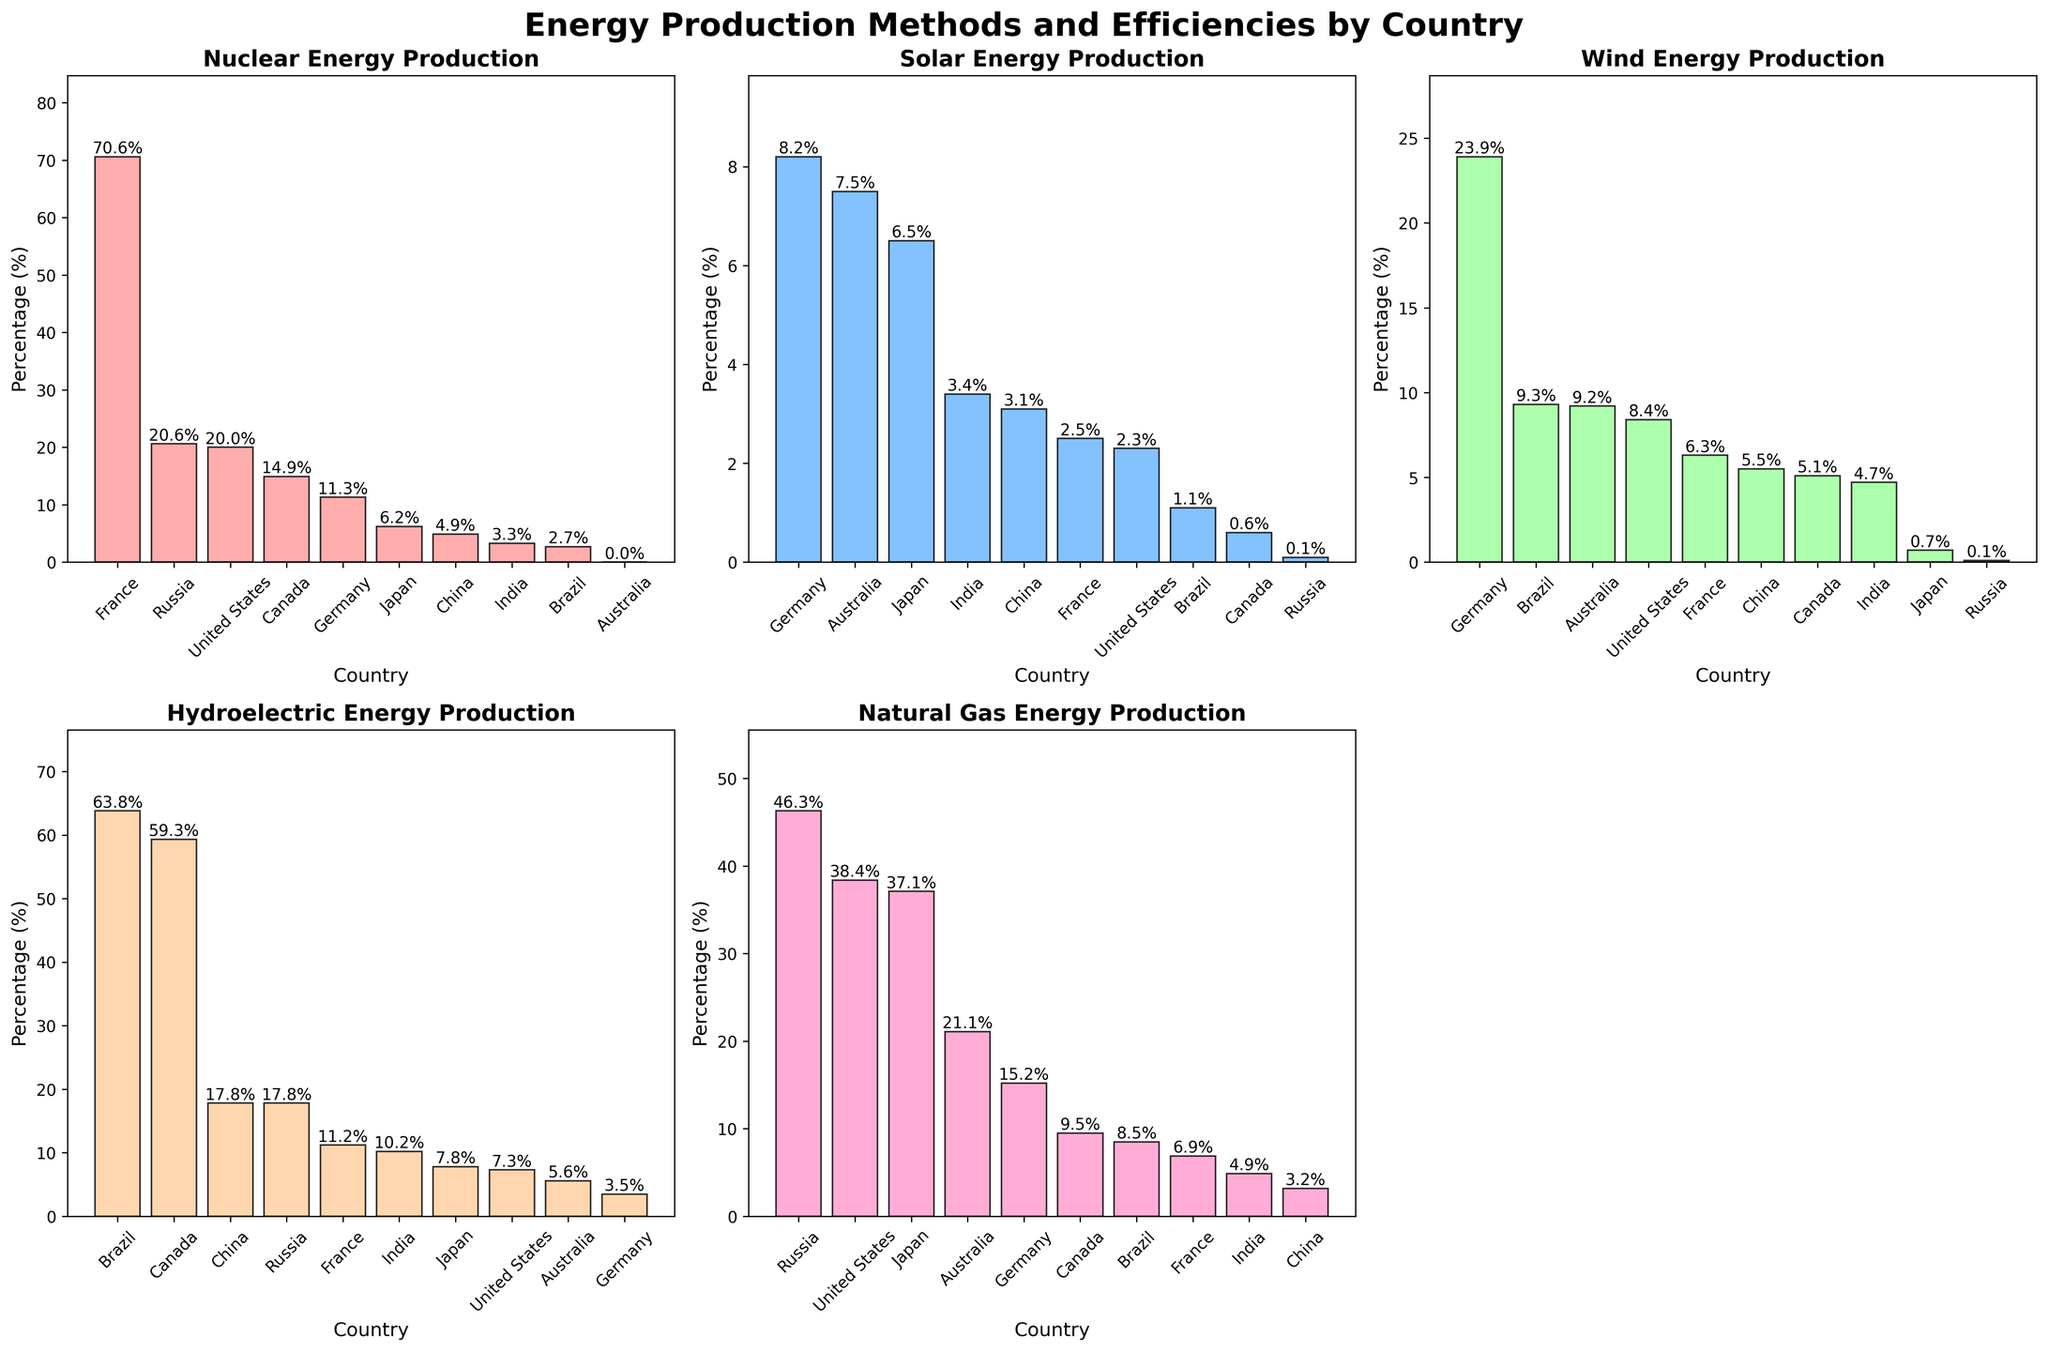What's the title of the overall figure? The title is displayed at the top center of the figure, indicating the subject of the plots. It reads "Energy Production Methods and Efficiencies by Country".
Answer: Energy Production Methods and Efficiencies by Country Which country has the highest wind energy production? The bar representing Germany is the tallest under the "Wind" subplot. This indicates that Germany has the highest percentage of wind energy production.
Answer: Germany What is the percentage of nuclear energy production in France? The bar corresponding to France in the "Nuclear" subplot has the highest value, which is clearly labeled at 70.6%.
Answer: 70.6% Compare the solar energy production of Germany and Australia. Which country has a higher percentage? In the "Solar" subplot, the bar for Germany is labeled with 8.2%, and the bar for Australia is labeled with 7.5%. Germany has a higher percentage.
Answer: Germany What is the sum of the hydroelectric energy production for Brazil and Canada? In the "Hydroelectric" subplot, the bar for Brazil shows 63.8% and the bar for Canada shows 59.3%. Summing these values gives 63.8 + 59.3 = 123.1%.
Answer: 123.1% Which country has the lowest percentage of solar energy production? The bar for Russia in the "Solar" subplot is the smallest and labeled with 0.1%.
Answer: Russia Which energy source has the highest percentage in the United States? In the "Natural Gas" subplot, the United States bar is the highest with a value of 38.4%, which is higher than its bars in the other subplots.
Answer: Natural Gas What is the average percentage of wind energy production among the countries listed? The values from the "Wind" subplot are 8.4, 6.3, 23.9, 5.5, 0.7, 9.3, 4.7, 0.1, 5.1, and 9.2, summing these gives 73.2. There are 10 countries, so the average is 73.2/10 = 7.32%.
Answer: 7.32% Which country shows a similar percentage in nuclear and natural gas energy production? The bar heights for Russia in both the "Nuclear" and "Natural Gas" subplots appear similar. The values are 20.6% for nuclear and 46.3% for natural gas.
Answer: Russia In the "Hydroelectric" subplot, which two countries have nearly the same percentage, and what is that percentage? Both China and Russia have bars at the same height of 17.8%.
Answer: China and Russia, 17.8% 